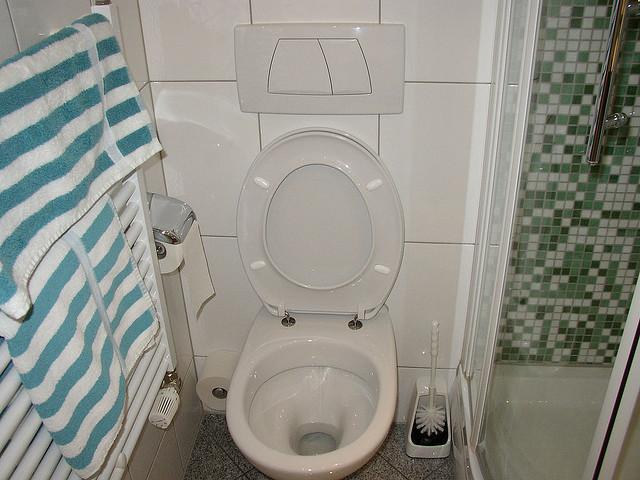Is the restroom clean?
Quick response, please. Yes. What is to the right of the toilet?
Be succinct. Shower. Which room is this?
Be succinct. Bathroom. What color are the shower tiles?
Write a very short answer. White. 